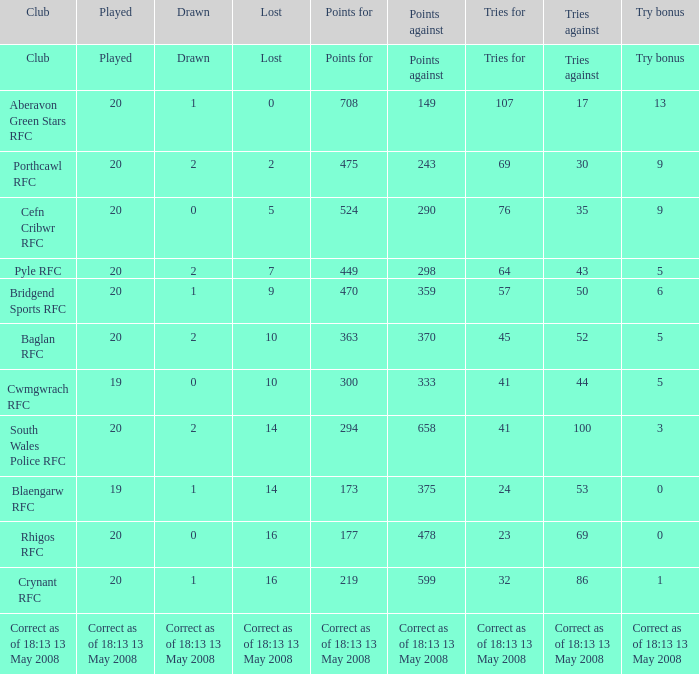What is the lost when the try bonus is 5, and points against is 298? 7.0. 